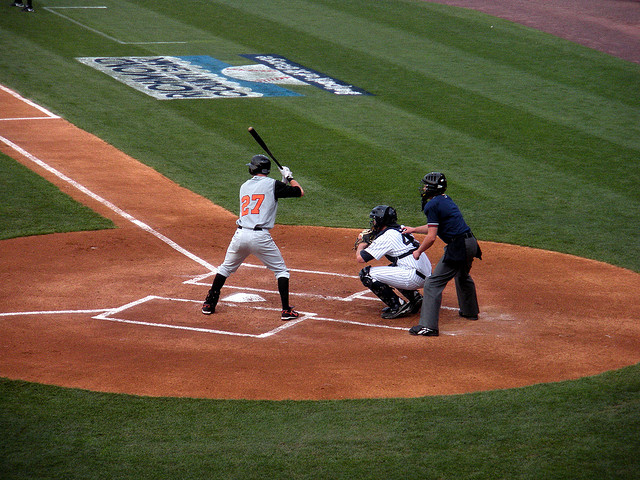Identify and read out the text in this image. 4 27 